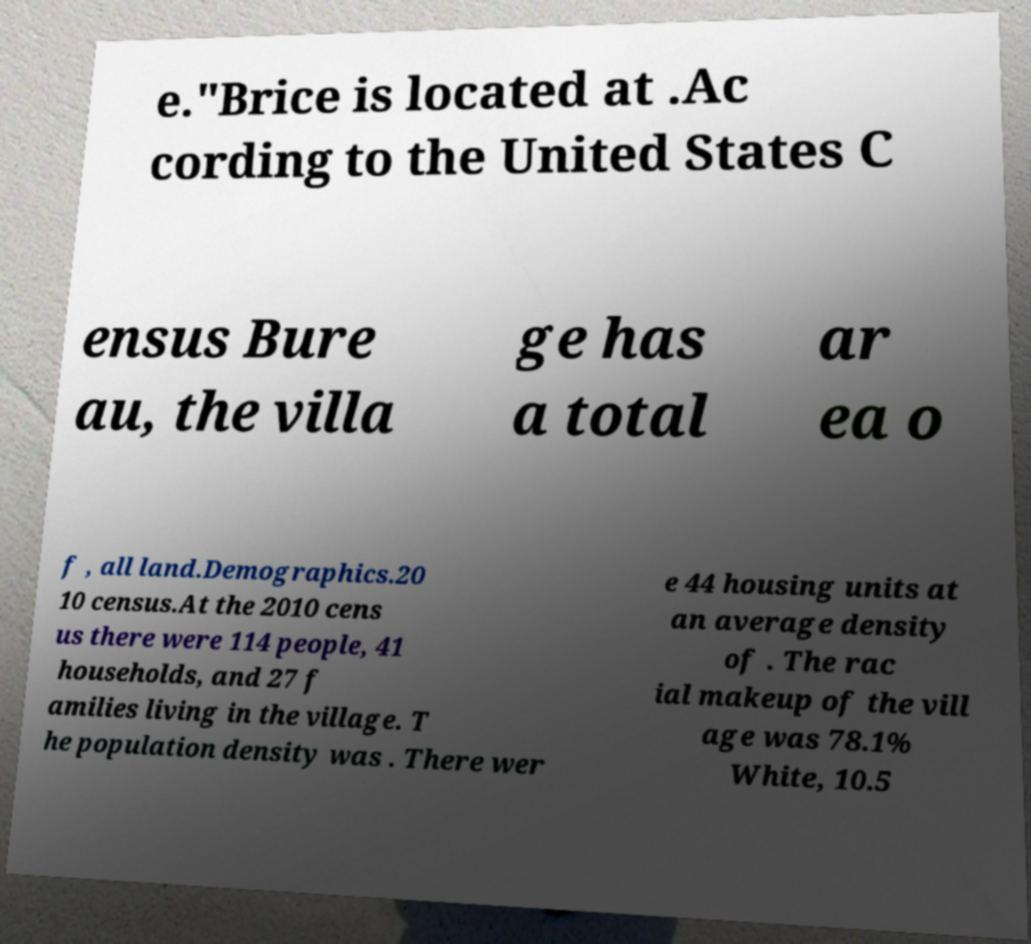Could you assist in decoding the text presented in this image and type it out clearly? e."Brice is located at .Ac cording to the United States C ensus Bure au, the villa ge has a total ar ea o f , all land.Demographics.20 10 census.At the 2010 cens us there were 114 people, 41 households, and 27 f amilies living in the village. T he population density was . There wer e 44 housing units at an average density of . The rac ial makeup of the vill age was 78.1% White, 10.5 